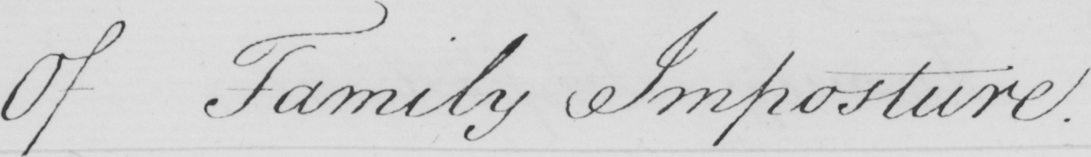Please transcribe the handwritten text in this image. Of Family Imposture . 